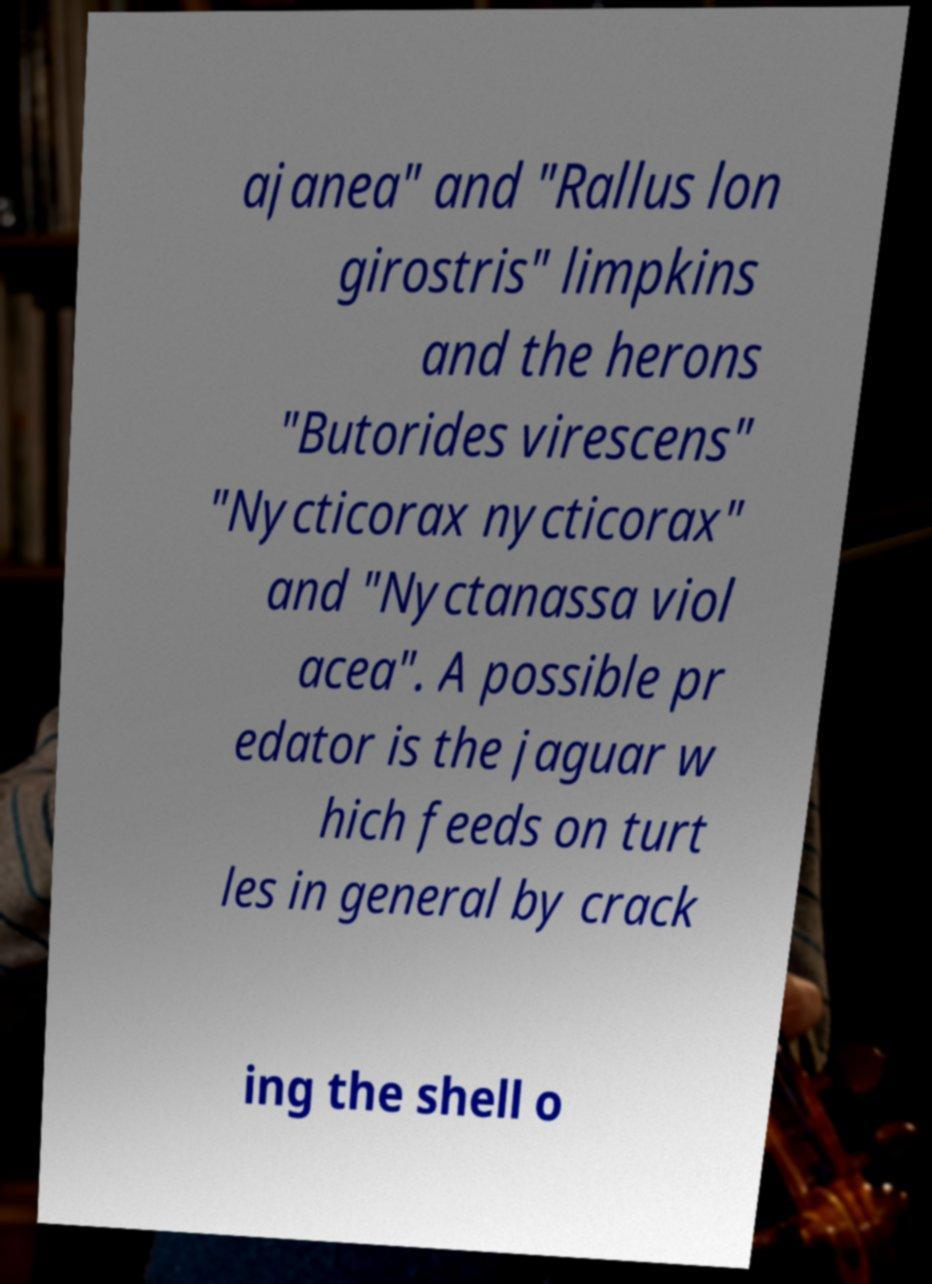For documentation purposes, I need the text within this image transcribed. Could you provide that? ajanea" and "Rallus lon girostris" limpkins and the herons "Butorides virescens" "Nycticorax nycticorax" and "Nyctanassa viol acea". A possible pr edator is the jaguar w hich feeds on turt les in general by crack ing the shell o 